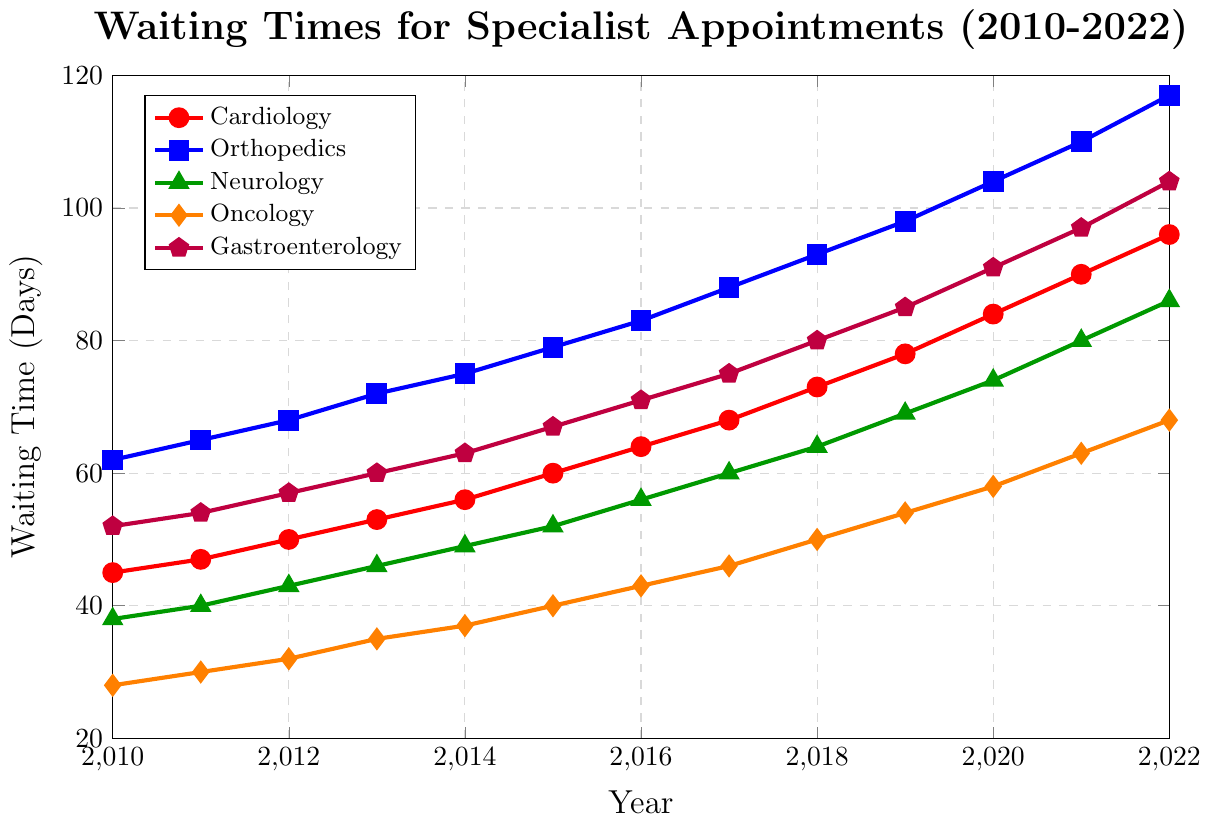What's the waiting time for Neurology in 2020? Observe the point for Neurology in the year 2020 and read the value. The green line for Neurology intersects the year 2020 at the 74 days mark.
Answer: 74 days Which medical field had the longest waiting time in 2013? Compare the waiting times for all medical fields in 2013. Orthopedics has the highest value of 72 days.
Answer: Orthopedics What is the overall trend for waiting times in Oncology from 2010 to 2022? By analyzing the orange line from 2010 to 2022, we can see it consistently rises from 28 to 68 days. Therefore, the trend is an increasing one.
Answer: Increasing By how much did the waiting time for Cardiology increase from 2010 to 2022? Subtract 2010's waiting time for Cardiology from 2022's waiting time. The values are 96 days in 2022 and 45 days in 2010, so the increase is 96 - 45 = 51 days.
Answer: 51 days Which two medical fields showed the smallest difference in waiting times in 2018? Look at the values for all medical fields in 2018. Oncology and Neurology have 50 and 64 days respectively. The difference is 64 - 50 = 14 days, which is the smallest compared to other pairs.
Answer: Oncology and Neurology What is the average waiting time for Gastroenterology over the given years? Add up all the waiting times for Gastroenterology from 2010 to 2022 and divide by the number of years (13): (52 + 54 + 57 + 60 + 63 + 67 + 71 + 75 + 80 + 85 + 91 + 97 + 104) / 13 = 76 days.
Answer: 76 days In which year did Orthopedics first exceed a 100-day waiting time? Follow the blue line for Orthopedics and find the year where the waiting time first crosses 100 days. In 2020, the waiting time is 104 days.
Answer: 2020 How do the waiting times for Neurology compare to Cardiology in 2015? Compare the values for Neurology and Cardiology in 2015. Neurology has 52 days and Cardiology has 60 days, so Neurology has a shorter waiting time.
Answer: Neurology What is the difference in waiting times between the longest and the shortest medical fields in 2021? In 2021, Orthopedics has the longest waiting time of 110 days and Oncology has the shortest at 63 days. The difference is 110 - 63 = 47 days.
Answer: 47 days 